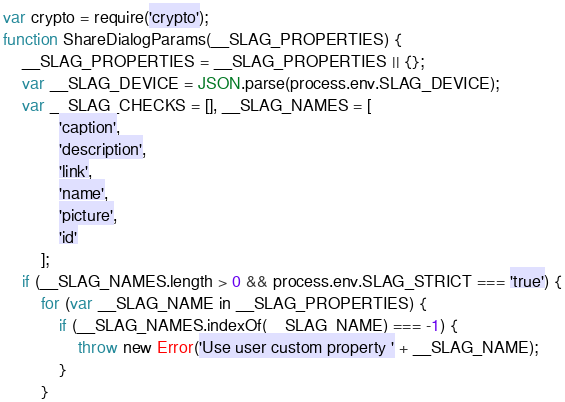Convert code to text. <code><loc_0><loc_0><loc_500><loc_500><_JavaScript_>var crypto = require('crypto');
function ShareDialogParams(__SLAG_PROPERTIES) {
	__SLAG_PROPERTIES = __SLAG_PROPERTIES || {};
	var __SLAG_DEVICE = JSON.parse(process.env.SLAG_DEVICE);
	var __SLAG_CHECKS = [], __SLAG_NAMES = [
			'caption',
			'description',
			'link',
			'name',
			'picture',
			'id'
		];
	if (__SLAG_NAMES.length > 0 && process.env.SLAG_STRICT === 'true') {
		for (var __SLAG_NAME in __SLAG_PROPERTIES) {
			if (__SLAG_NAMES.indexOf(__SLAG_NAME) === -1) {
				throw new Error('Use user custom property ' + __SLAG_NAME);
			}
		}</code> 